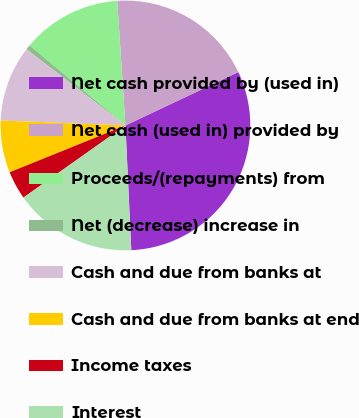<chart> <loc_0><loc_0><loc_500><loc_500><pie_chart><fcel>Net cash provided by (used in)<fcel>Net cash (used in) provided by<fcel>Proceeds/(repayments) from<fcel>Net (decrease) increase in<fcel>Cash and due from banks at<fcel>Cash and due from banks at end<fcel>Income taxes<fcel>Interest<nl><fcel>31.28%<fcel>19.02%<fcel>12.88%<fcel>0.62%<fcel>9.82%<fcel>6.75%<fcel>3.68%<fcel>15.95%<nl></chart> 